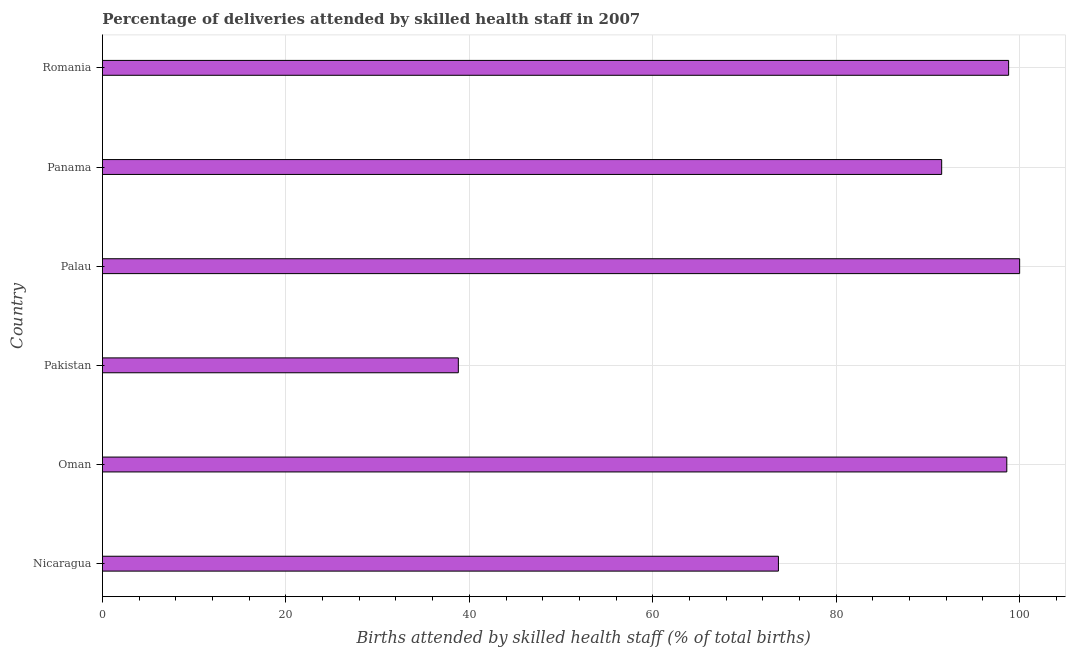Does the graph contain any zero values?
Make the answer very short. No. Does the graph contain grids?
Ensure brevity in your answer.  Yes. What is the title of the graph?
Your answer should be compact. Percentage of deliveries attended by skilled health staff in 2007. What is the label or title of the X-axis?
Ensure brevity in your answer.  Births attended by skilled health staff (% of total births). What is the number of births attended by skilled health staff in Nicaragua?
Keep it short and to the point. 73.7. Across all countries, what is the minimum number of births attended by skilled health staff?
Offer a very short reply. 38.8. In which country was the number of births attended by skilled health staff maximum?
Your response must be concise. Palau. In which country was the number of births attended by skilled health staff minimum?
Your answer should be compact. Pakistan. What is the sum of the number of births attended by skilled health staff?
Provide a succinct answer. 501.4. What is the difference between the number of births attended by skilled health staff in Oman and Pakistan?
Your answer should be very brief. 59.8. What is the average number of births attended by skilled health staff per country?
Offer a very short reply. 83.57. What is the median number of births attended by skilled health staff?
Provide a short and direct response. 95.05. What is the ratio of the number of births attended by skilled health staff in Pakistan to that in Panama?
Provide a succinct answer. 0.42. Is the number of births attended by skilled health staff in Nicaragua less than that in Pakistan?
Provide a succinct answer. No. Is the difference between the number of births attended by skilled health staff in Oman and Pakistan greater than the difference between any two countries?
Your answer should be compact. No. Is the sum of the number of births attended by skilled health staff in Panama and Romania greater than the maximum number of births attended by skilled health staff across all countries?
Offer a very short reply. Yes. What is the difference between the highest and the lowest number of births attended by skilled health staff?
Make the answer very short. 61.2. What is the difference between two consecutive major ticks on the X-axis?
Offer a very short reply. 20. Are the values on the major ticks of X-axis written in scientific E-notation?
Make the answer very short. No. What is the Births attended by skilled health staff (% of total births) in Nicaragua?
Your answer should be very brief. 73.7. What is the Births attended by skilled health staff (% of total births) of Oman?
Your answer should be very brief. 98.6. What is the Births attended by skilled health staff (% of total births) in Pakistan?
Make the answer very short. 38.8. What is the Births attended by skilled health staff (% of total births) in Panama?
Provide a short and direct response. 91.5. What is the Births attended by skilled health staff (% of total births) in Romania?
Ensure brevity in your answer.  98.8. What is the difference between the Births attended by skilled health staff (% of total births) in Nicaragua and Oman?
Your response must be concise. -24.9. What is the difference between the Births attended by skilled health staff (% of total births) in Nicaragua and Pakistan?
Offer a terse response. 34.9. What is the difference between the Births attended by skilled health staff (% of total births) in Nicaragua and Palau?
Your answer should be very brief. -26.3. What is the difference between the Births attended by skilled health staff (% of total births) in Nicaragua and Panama?
Ensure brevity in your answer.  -17.8. What is the difference between the Births attended by skilled health staff (% of total births) in Nicaragua and Romania?
Ensure brevity in your answer.  -25.1. What is the difference between the Births attended by skilled health staff (% of total births) in Oman and Pakistan?
Provide a short and direct response. 59.8. What is the difference between the Births attended by skilled health staff (% of total births) in Oman and Panama?
Offer a terse response. 7.1. What is the difference between the Births attended by skilled health staff (% of total births) in Oman and Romania?
Your answer should be very brief. -0.2. What is the difference between the Births attended by skilled health staff (% of total births) in Pakistan and Palau?
Make the answer very short. -61.2. What is the difference between the Births attended by skilled health staff (% of total births) in Pakistan and Panama?
Your answer should be compact. -52.7. What is the difference between the Births attended by skilled health staff (% of total births) in Pakistan and Romania?
Provide a succinct answer. -60. What is the difference between the Births attended by skilled health staff (% of total births) in Palau and Romania?
Offer a very short reply. 1.2. What is the ratio of the Births attended by skilled health staff (% of total births) in Nicaragua to that in Oman?
Offer a very short reply. 0.75. What is the ratio of the Births attended by skilled health staff (% of total births) in Nicaragua to that in Pakistan?
Ensure brevity in your answer.  1.9. What is the ratio of the Births attended by skilled health staff (% of total births) in Nicaragua to that in Palau?
Your answer should be very brief. 0.74. What is the ratio of the Births attended by skilled health staff (% of total births) in Nicaragua to that in Panama?
Keep it short and to the point. 0.81. What is the ratio of the Births attended by skilled health staff (% of total births) in Nicaragua to that in Romania?
Provide a short and direct response. 0.75. What is the ratio of the Births attended by skilled health staff (% of total births) in Oman to that in Pakistan?
Offer a terse response. 2.54. What is the ratio of the Births attended by skilled health staff (% of total births) in Oman to that in Palau?
Give a very brief answer. 0.99. What is the ratio of the Births attended by skilled health staff (% of total births) in Oman to that in Panama?
Make the answer very short. 1.08. What is the ratio of the Births attended by skilled health staff (% of total births) in Pakistan to that in Palau?
Offer a terse response. 0.39. What is the ratio of the Births attended by skilled health staff (% of total births) in Pakistan to that in Panama?
Offer a terse response. 0.42. What is the ratio of the Births attended by skilled health staff (% of total births) in Pakistan to that in Romania?
Ensure brevity in your answer.  0.39. What is the ratio of the Births attended by skilled health staff (% of total births) in Palau to that in Panama?
Your answer should be compact. 1.09. What is the ratio of the Births attended by skilled health staff (% of total births) in Panama to that in Romania?
Offer a terse response. 0.93. 